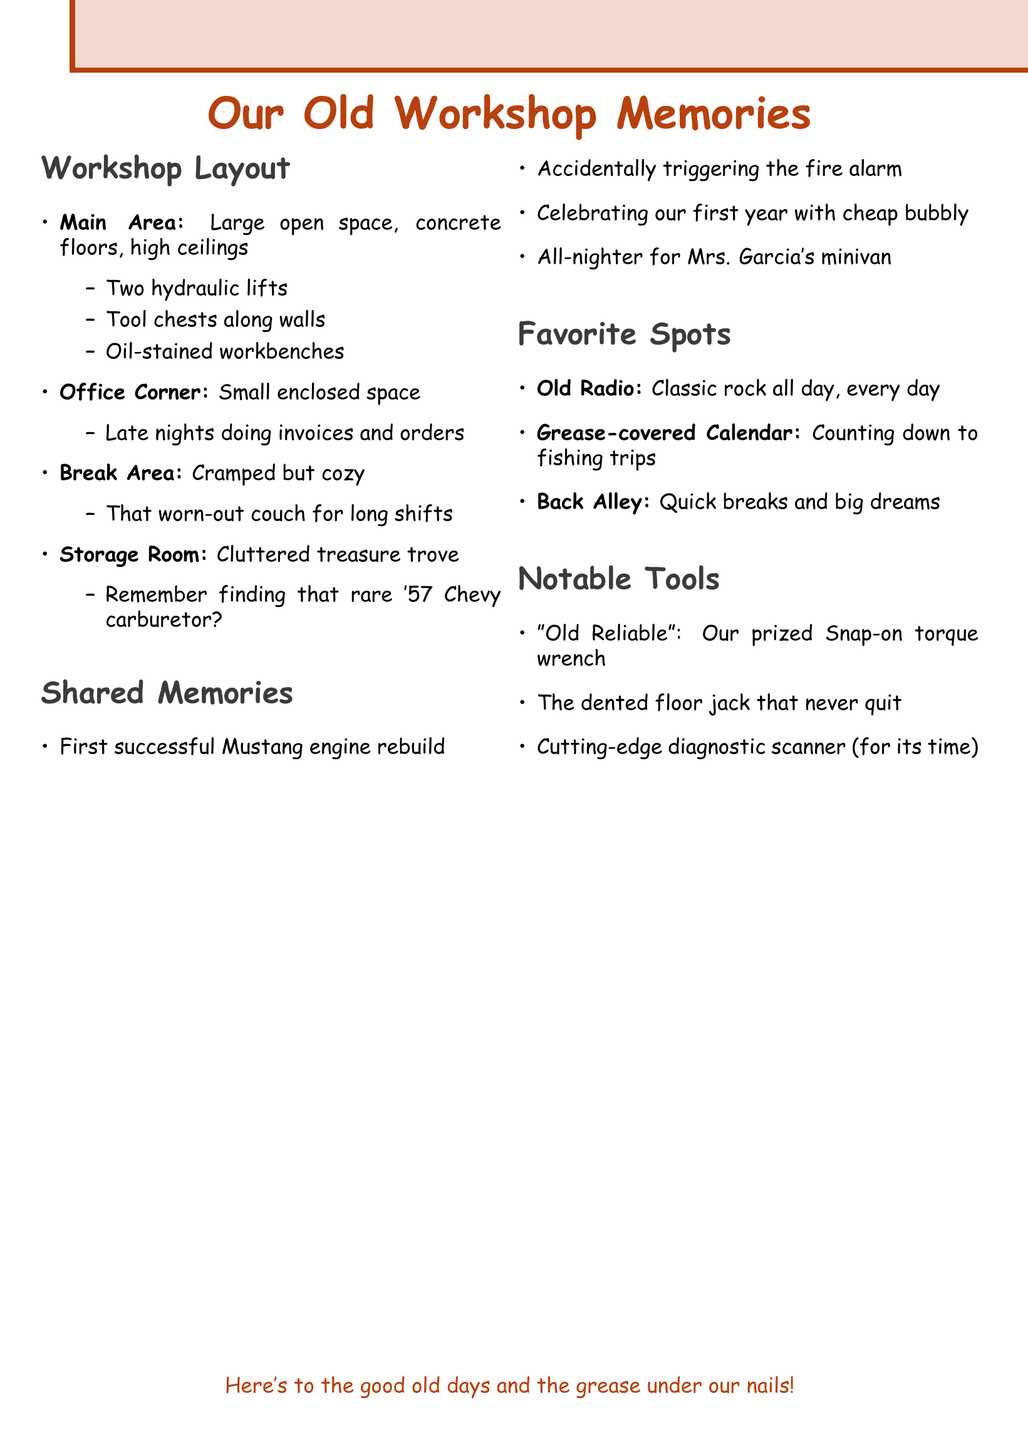What is the main area of the workshop like? The main area is described as a large open space with concrete floors and high ceilings.
Answer: Large open space, concrete floors, high ceilings What is remembered about the office corner? The memory associated with the office corner involves late nights spent on invoices and parts orders.
Answer: Late nights doing invoices and orders What occupied space is cluttered with spare parts? The space described as cluttered with spare parts and old equipment is the storage room.
Answer: Storage room Which tool is referred to as "Old Reliable"? "Old Reliable" is the Snap-on torque wrench that they saved up for months to buy.
Answer: Snap-on torque wrench What favorite spot is associated with classic rock? The old radio on the workbench is associated with classic rock music.
Answer: Old Radio How many shared memories are noted in the document? The document lists four shared memories shared among the apprentices.
Answer: Four What was the favorite spot where they would sneak out? The back alley is noted as the favorite spot where they would sneak out for quick breaks.
Answer: Back Alley What was a notable event during their first year in business? They celebrated their first year in business with cheap champagne.
Answer: Cheap champagne 